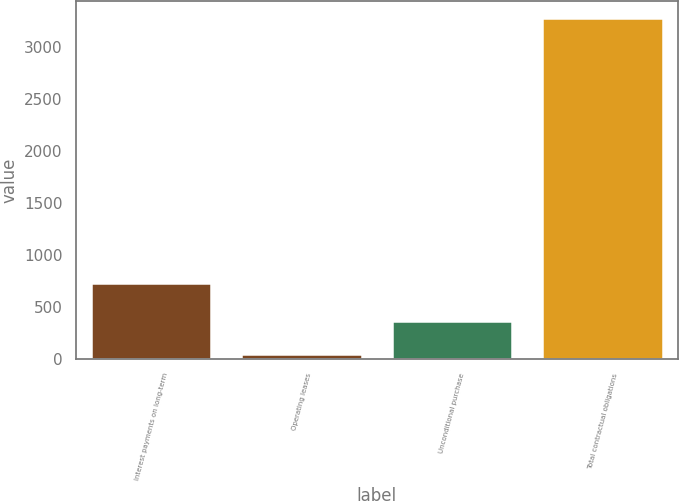Convert chart to OTSL. <chart><loc_0><loc_0><loc_500><loc_500><bar_chart><fcel>Interest payments on long-term<fcel>Operating leases<fcel>Unconditional purchase<fcel>Total contractual obligations<nl><fcel>735<fcel>47<fcel>370.4<fcel>3281<nl></chart> 